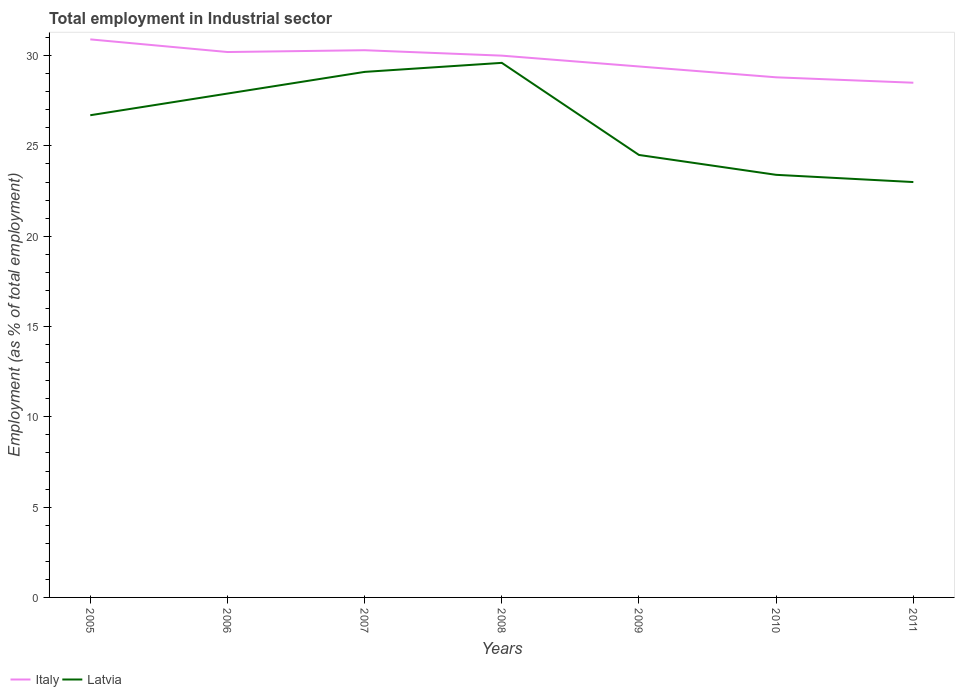How many different coloured lines are there?
Ensure brevity in your answer.  2. Does the line corresponding to Italy intersect with the line corresponding to Latvia?
Your answer should be compact. No. Is the number of lines equal to the number of legend labels?
Your response must be concise. Yes. In which year was the employment in industrial sector in Latvia maximum?
Your response must be concise. 2011. What is the total employment in industrial sector in Italy in the graph?
Provide a succinct answer. 0.7. What is the difference between the highest and the second highest employment in industrial sector in Latvia?
Provide a succinct answer. 6.6. What is the difference between the highest and the lowest employment in industrial sector in Latvia?
Your answer should be compact. 4. How many years are there in the graph?
Provide a short and direct response. 7. What is the difference between two consecutive major ticks on the Y-axis?
Provide a short and direct response. 5. Are the values on the major ticks of Y-axis written in scientific E-notation?
Ensure brevity in your answer.  No. How are the legend labels stacked?
Your response must be concise. Horizontal. What is the title of the graph?
Ensure brevity in your answer.  Total employment in Industrial sector. What is the label or title of the Y-axis?
Offer a terse response. Employment (as % of total employment). What is the Employment (as % of total employment) of Italy in 2005?
Give a very brief answer. 30.9. What is the Employment (as % of total employment) of Latvia in 2005?
Your answer should be very brief. 26.7. What is the Employment (as % of total employment) in Italy in 2006?
Ensure brevity in your answer.  30.2. What is the Employment (as % of total employment) in Latvia in 2006?
Your response must be concise. 27.9. What is the Employment (as % of total employment) of Italy in 2007?
Provide a succinct answer. 30.3. What is the Employment (as % of total employment) in Latvia in 2007?
Give a very brief answer. 29.1. What is the Employment (as % of total employment) in Italy in 2008?
Make the answer very short. 30. What is the Employment (as % of total employment) in Latvia in 2008?
Your answer should be very brief. 29.6. What is the Employment (as % of total employment) in Italy in 2009?
Your answer should be very brief. 29.4. What is the Employment (as % of total employment) of Latvia in 2009?
Keep it short and to the point. 24.5. What is the Employment (as % of total employment) of Italy in 2010?
Ensure brevity in your answer.  28.8. What is the Employment (as % of total employment) of Latvia in 2010?
Keep it short and to the point. 23.4. What is the Employment (as % of total employment) in Latvia in 2011?
Offer a terse response. 23. Across all years, what is the maximum Employment (as % of total employment) of Italy?
Make the answer very short. 30.9. Across all years, what is the maximum Employment (as % of total employment) in Latvia?
Give a very brief answer. 29.6. Across all years, what is the minimum Employment (as % of total employment) of Italy?
Your answer should be very brief. 28.5. What is the total Employment (as % of total employment) of Italy in the graph?
Your answer should be very brief. 208.1. What is the total Employment (as % of total employment) of Latvia in the graph?
Your answer should be very brief. 184.2. What is the difference between the Employment (as % of total employment) of Latvia in 2005 and that in 2006?
Ensure brevity in your answer.  -1.2. What is the difference between the Employment (as % of total employment) in Latvia in 2005 and that in 2008?
Your response must be concise. -2.9. What is the difference between the Employment (as % of total employment) of Latvia in 2005 and that in 2009?
Give a very brief answer. 2.2. What is the difference between the Employment (as % of total employment) in Latvia in 2005 and that in 2010?
Provide a succinct answer. 3.3. What is the difference between the Employment (as % of total employment) of Italy in 2006 and that in 2007?
Ensure brevity in your answer.  -0.1. What is the difference between the Employment (as % of total employment) in Italy in 2006 and that in 2008?
Ensure brevity in your answer.  0.2. What is the difference between the Employment (as % of total employment) in Latvia in 2006 and that in 2008?
Give a very brief answer. -1.7. What is the difference between the Employment (as % of total employment) of Italy in 2006 and that in 2010?
Make the answer very short. 1.4. What is the difference between the Employment (as % of total employment) in Latvia in 2006 and that in 2010?
Make the answer very short. 4.5. What is the difference between the Employment (as % of total employment) in Latvia in 2006 and that in 2011?
Offer a very short reply. 4.9. What is the difference between the Employment (as % of total employment) in Latvia in 2007 and that in 2008?
Your response must be concise. -0.5. What is the difference between the Employment (as % of total employment) in Italy in 2007 and that in 2009?
Offer a very short reply. 0.9. What is the difference between the Employment (as % of total employment) of Latvia in 2007 and that in 2009?
Provide a short and direct response. 4.6. What is the difference between the Employment (as % of total employment) in Italy in 2007 and that in 2010?
Ensure brevity in your answer.  1.5. What is the difference between the Employment (as % of total employment) of Latvia in 2007 and that in 2010?
Offer a very short reply. 5.7. What is the difference between the Employment (as % of total employment) of Latvia in 2008 and that in 2010?
Give a very brief answer. 6.2. What is the difference between the Employment (as % of total employment) in Italy in 2008 and that in 2011?
Make the answer very short. 1.5. What is the difference between the Employment (as % of total employment) of Latvia in 2009 and that in 2010?
Your response must be concise. 1.1. What is the difference between the Employment (as % of total employment) of Italy in 2010 and that in 2011?
Provide a succinct answer. 0.3. What is the difference between the Employment (as % of total employment) in Latvia in 2010 and that in 2011?
Provide a short and direct response. 0.4. What is the difference between the Employment (as % of total employment) in Italy in 2005 and the Employment (as % of total employment) in Latvia in 2006?
Provide a short and direct response. 3. What is the difference between the Employment (as % of total employment) in Italy in 2005 and the Employment (as % of total employment) in Latvia in 2008?
Offer a terse response. 1.3. What is the difference between the Employment (as % of total employment) of Italy in 2005 and the Employment (as % of total employment) of Latvia in 2009?
Provide a succinct answer. 6.4. What is the difference between the Employment (as % of total employment) in Italy in 2005 and the Employment (as % of total employment) in Latvia in 2011?
Ensure brevity in your answer.  7.9. What is the difference between the Employment (as % of total employment) in Italy in 2006 and the Employment (as % of total employment) in Latvia in 2007?
Your response must be concise. 1.1. What is the difference between the Employment (as % of total employment) in Italy in 2006 and the Employment (as % of total employment) in Latvia in 2008?
Make the answer very short. 0.6. What is the difference between the Employment (as % of total employment) in Italy in 2006 and the Employment (as % of total employment) in Latvia in 2011?
Provide a succinct answer. 7.2. What is the difference between the Employment (as % of total employment) in Italy in 2007 and the Employment (as % of total employment) in Latvia in 2008?
Make the answer very short. 0.7. What is the difference between the Employment (as % of total employment) of Italy in 2007 and the Employment (as % of total employment) of Latvia in 2009?
Your response must be concise. 5.8. What is the difference between the Employment (as % of total employment) in Italy in 2007 and the Employment (as % of total employment) in Latvia in 2010?
Ensure brevity in your answer.  6.9. What is the difference between the Employment (as % of total employment) in Italy in 2008 and the Employment (as % of total employment) in Latvia in 2009?
Make the answer very short. 5.5. What is the difference between the Employment (as % of total employment) of Italy in 2008 and the Employment (as % of total employment) of Latvia in 2010?
Your response must be concise. 6.6. What is the difference between the Employment (as % of total employment) in Italy in 2008 and the Employment (as % of total employment) in Latvia in 2011?
Provide a succinct answer. 7. What is the difference between the Employment (as % of total employment) of Italy in 2009 and the Employment (as % of total employment) of Latvia in 2011?
Your response must be concise. 6.4. What is the difference between the Employment (as % of total employment) in Italy in 2010 and the Employment (as % of total employment) in Latvia in 2011?
Keep it short and to the point. 5.8. What is the average Employment (as % of total employment) of Italy per year?
Your response must be concise. 29.73. What is the average Employment (as % of total employment) in Latvia per year?
Offer a terse response. 26.31. In the year 2005, what is the difference between the Employment (as % of total employment) of Italy and Employment (as % of total employment) of Latvia?
Provide a succinct answer. 4.2. In the year 2008, what is the difference between the Employment (as % of total employment) in Italy and Employment (as % of total employment) in Latvia?
Make the answer very short. 0.4. In the year 2009, what is the difference between the Employment (as % of total employment) of Italy and Employment (as % of total employment) of Latvia?
Provide a succinct answer. 4.9. In the year 2010, what is the difference between the Employment (as % of total employment) of Italy and Employment (as % of total employment) of Latvia?
Your answer should be compact. 5.4. In the year 2011, what is the difference between the Employment (as % of total employment) of Italy and Employment (as % of total employment) of Latvia?
Provide a short and direct response. 5.5. What is the ratio of the Employment (as % of total employment) in Italy in 2005 to that in 2006?
Keep it short and to the point. 1.02. What is the ratio of the Employment (as % of total employment) in Latvia in 2005 to that in 2006?
Your answer should be compact. 0.96. What is the ratio of the Employment (as % of total employment) in Italy in 2005 to that in 2007?
Ensure brevity in your answer.  1.02. What is the ratio of the Employment (as % of total employment) of Latvia in 2005 to that in 2007?
Offer a terse response. 0.92. What is the ratio of the Employment (as % of total employment) of Italy in 2005 to that in 2008?
Offer a very short reply. 1.03. What is the ratio of the Employment (as % of total employment) in Latvia in 2005 to that in 2008?
Your answer should be compact. 0.9. What is the ratio of the Employment (as % of total employment) in Italy in 2005 to that in 2009?
Your answer should be very brief. 1.05. What is the ratio of the Employment (as % of total employment) in Latvia in 2005 to that in 2009?
Your answer should be very brief. 1.09. What is the ratio of the Employment (as % of total employment) of Italy in 2005 to that in 2010?
Keep it short and to the point. 1.07. What is the ratio of the Employment (as % of total employment) in Latvia in 2005 to that in 2010?
Give a very brief answer. 1.14. What is the ratio of the Employment (as % of total employment) of Italy in 2005 to that in 2011?
Provide a short and direct response. 1.08. What is the ratio of the Employment (as % of total employment) in Latvia in 2005 to that in 2011?
Your answer should be very brief. 1.16. What is the ratio of the Employment (as % of total employment) in Latvia in 2006 to that in 2007?
Provide a succinct answer. 0.96. What is the ratio of the Employment (as % of total employment) in Latvia in 2006 to that in 2008?
Ensure brevity in your answer.  0.94. What is the ratio of the Employment (as % of total employment) of Italy in 2006 to that in 2009?
Provide a succinct answer. 1.03. What is the ratio of the Employment (as % of total employment) of Latvia in 2006 to that in 2009?
Give a very brief answer. 1.14. What is the ratio of the Employment (as % of total employment) of Italy in 2006 to that in 2010?
Offer a terse response. 1.05. What is the ratio of the Employment (as % of total employment) in Latvia in 2006 to that in 2010?
Give a very brief answer. 1.19. What is the ratio of the Employment (as % of total employment) of Italy in 2006 to that in 2011?
Your answer should be compact. 1.06. What is the ratio of the Employment (as % of total employment) in Latvia in 2006 to that in 2011?
Provide a succinct answer. 1.21. What is the ratio of the Employment (as % of total employment) of Italy in 2007 to that in 2008?
Keep it short and to the point. 1.01. What is the ratio of the Employment (as % of total employment) of Latvia in 2007 to that in 2008?
Offer a very short reply. 0.98. What is the ratio of the Employment (as % of total employment) of Italy in 2007 to that in 2009?
Your answer should be very brief. 1.03. What is the ratio of the Employment (as % of total employment) in Latvia in 2007 to that in 2009?
Give a very brief answer. 1.19. What is the ratio of the Employment (as % of total employment) in Italy in 2007 to that in 2010?
Your answer should be very brief. 1.05. What is the ratio of the Employment (as % of total employment) of Latvia in 2007 to that in 2010?
Keep it short and to the point. 1.24. What is the ratio of the Employment (as % of total employment) of Italy in 2007 to that in 2011?
Your response must be concise. 1.06. What is the ratio of the Employment (as % of total employment) in Latvia in 2007 to that in 2011?
Provide a short and direct response. 1.27. What is the ratio of the Employment (as % of total employment) of Italy in 2008 to that in 2009?
Offer a very short reply. 1.02. What is the ratio of the Employment (as % of total employment) in Latvia in 2008 to that in 2009?
Ensure brevity in your answer.  1.21. What is the ratio of the Employment (as % of total employment) in Italy in 2008 to that in 2010?
Ensure brevity in your answer.  1.04. What is the ratio of the Employment (as % of total employment) in Latvia in 2008 to that in 2010?
Ensure brevity in your answer.  1.26. What is the ratio of the Employment (as % of total employment) of Italy in 2008 to that in 2011?
Make the answer very short. 1.05. What is the ratio of the Employment (as % of total employment) of Latvia in 2008 to that in 2011?
Make the answer very short. 1.29. What is the ratio of the Employment (as % of total employment) of Italy in 2009 to that in 2010?
Provide a succinct answer. 1.02. What is the ratio of the Employment (as % of total employment) of Latvia in 2009 to that in 2010?
Offer a terse response. 1.05. What is the ratio of the Employment (as % of total employment) in Italy in 2009 to that in 2011?
Keep it short and to the point. 1.03. What is the ratio of the Employment (as % of total employment) in Latvia in 2009 to that in 2011?
Provide a succinct answer. 1.07. What is the ratio of the Employment (as % of total employment) in Italy in 2010 to that in 2011?
Your answer should be very brief. 1.01. What is the ratio of the Employment (as % of total employment) of Latvia in 2010 to that in 2011?
Keep it short and to the point. 1.02. What is the difference between the highest and the second highest Employment (as % of total employment) in Italy?
Your answer should be very brief. 0.6. What is the difference between the highest and the lowest Employment (as % of total employment) in Italy?
Make the answer very short. 2.4. 